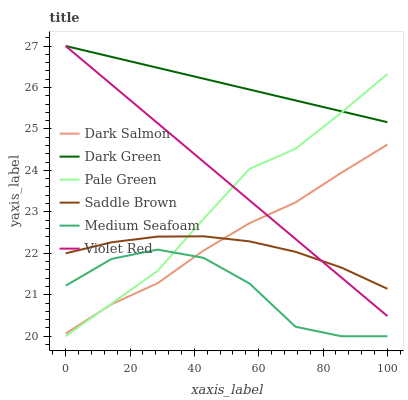Does Medium Seafoam have the minimum area under the curve?
Answer yes or no. Yes. Does Dark Green have the maximum area under the curve?
Answer yes or no. Yes. Does Dark Salmon have the minimum area under the curve?
Answer yes or no. No. Does Dark Salmon have the maximum area under the curve?
Answer yes or no. No. Is Dark Green the smoothest?
Answer yes or no. Yes. Is Medium Seafoam the roughest?
Answer yes or no. Yes. Is Dark Salmon the smoothest?
Answer yes or no. No. Is Dark Salmon the roughest?
Answer yes or no. No. Does Dark Salmon have the lowest value?
Answer yes or no. No. Does Dark Green have the highest value?
Answer yes or no. Yes. Does Dark Salmon have the highest value?
Answer yes or no. No. Is Medium Seafoam less than Violet Red?
Answer yes or no. Yes. Is Violet Red greater than Medium Seafoam?
Answer yes or no. Yes. Does Dark Salmon intersect Medium Seafoam?
Answer yes or no. Yes. Is Dark Salmon less than Medium Seafoam?
Answer yes or no. No. Is Dark Salmon greater than Medium Seafoam?
Answer yes or no. No. Does Medium Seafoam intersect Violet Red?
Answer yes or no. No. 